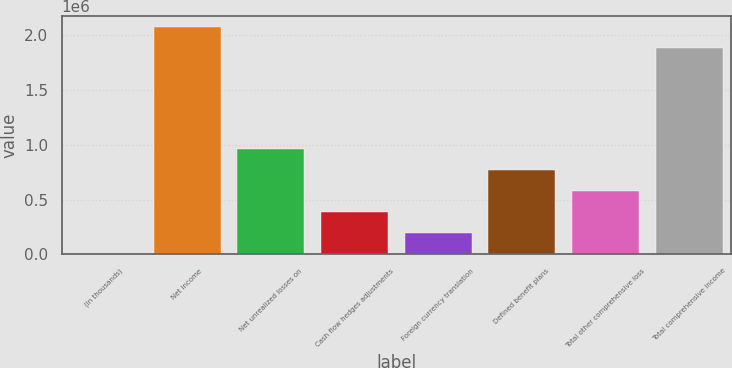Convert chart. <chart><loc_0><loc_0><loc_500><loc_500><bar_chart><fcel>(In thousands)<fcel>Net income<fcel>Net unrealized losses on<fcel>Cash flow hedges adjustments<fcel>Foreign currency translation<fcel>Defined benefit plans<fcel>Total other comprehensive loss<fcel>Total comprehensive income<nl><fcel>2018<fcel>2.07027e+06<fcel>960049<fcel>385230<fcel>193624<fcel>768443<fcel>576837<fcel>1.87867e+06<nl></chart> 